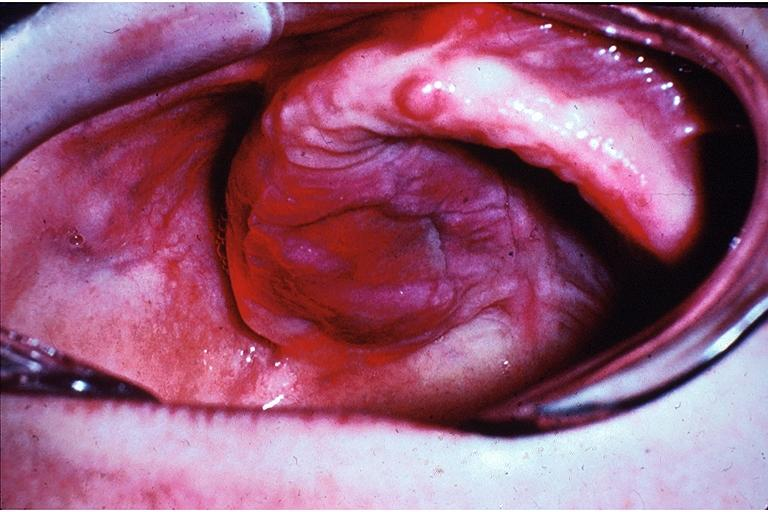what is present?
Answer the question using a single word or phrase. Oral 